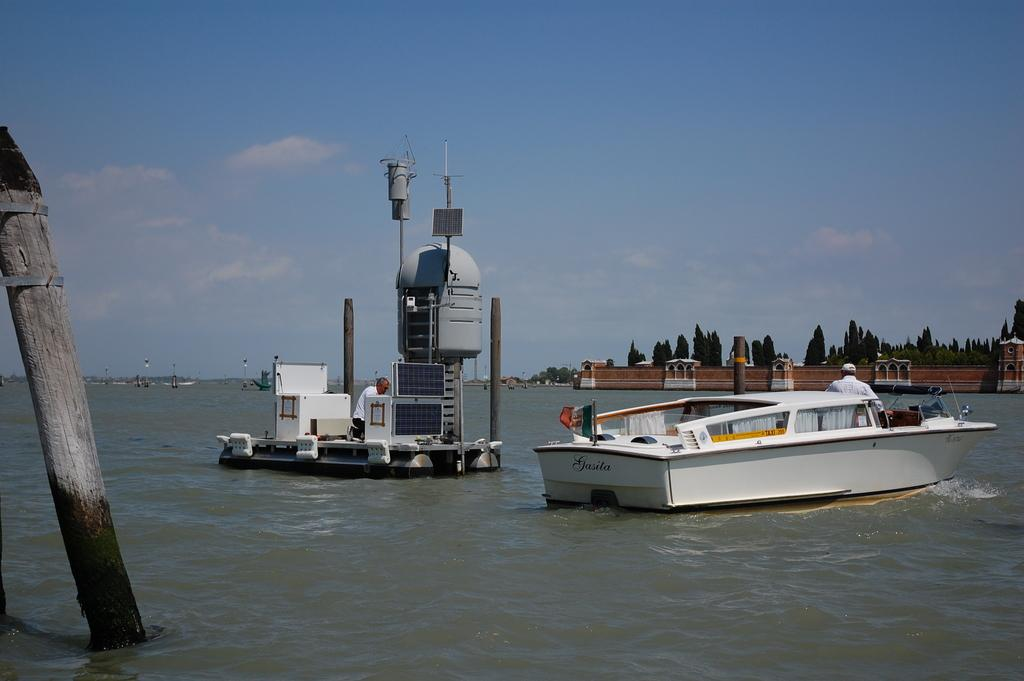What is the main object in the image? There is a wooden pole in the image. What activity is taking place in the image? Boats are sailing on the water in the image. What structure can be seen on the right side of the image? There is a building on the right side of the image. What is the condition of the sky in the image? The sky is clear in the image. What type of cloth is being used to make the balls in the image? There are no balls or cloth present in the image; it features a wooden pole, boats sailing on the water, a building, and a clear sky. 